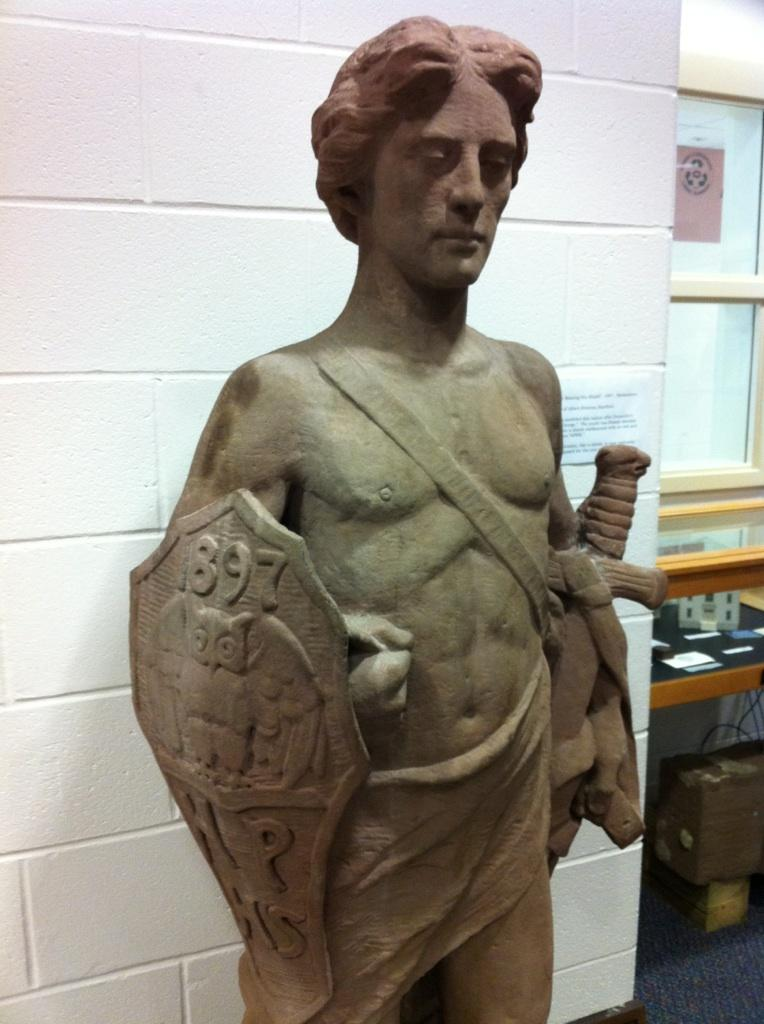What is the statue in the image holding? The statue is holding a shield and a knife. What is located to the right of the statue? There is a table to the right of the statue. What is located to the right of the table? There is a window to the right of the table. What type of lipstick is the fireman wearing in the image? There is no fireman or lipstick present in the image. How is the thread being used in the image? There is no thread present in the image. 